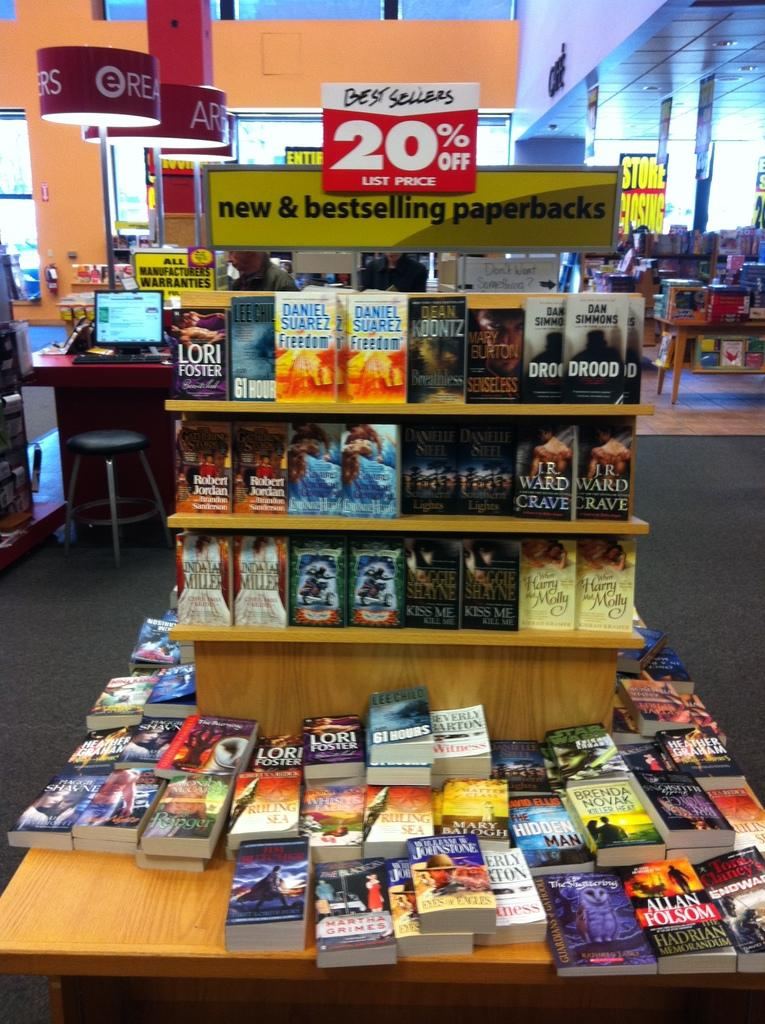<image>
Summarize the visual content of the image. A book stand full of books that are 20% off. 